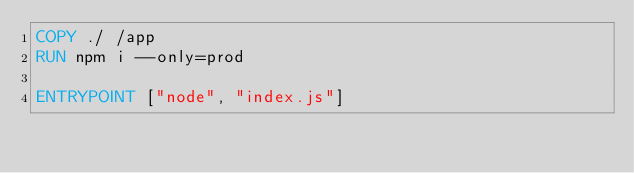<code> <loc_0><loc_0><loc_500><loc_500><_Dockerfile_>COPY ./ /app
RUN npm i --only=prod

ENTRYPOINT ["node", "index.js"]
</code> 